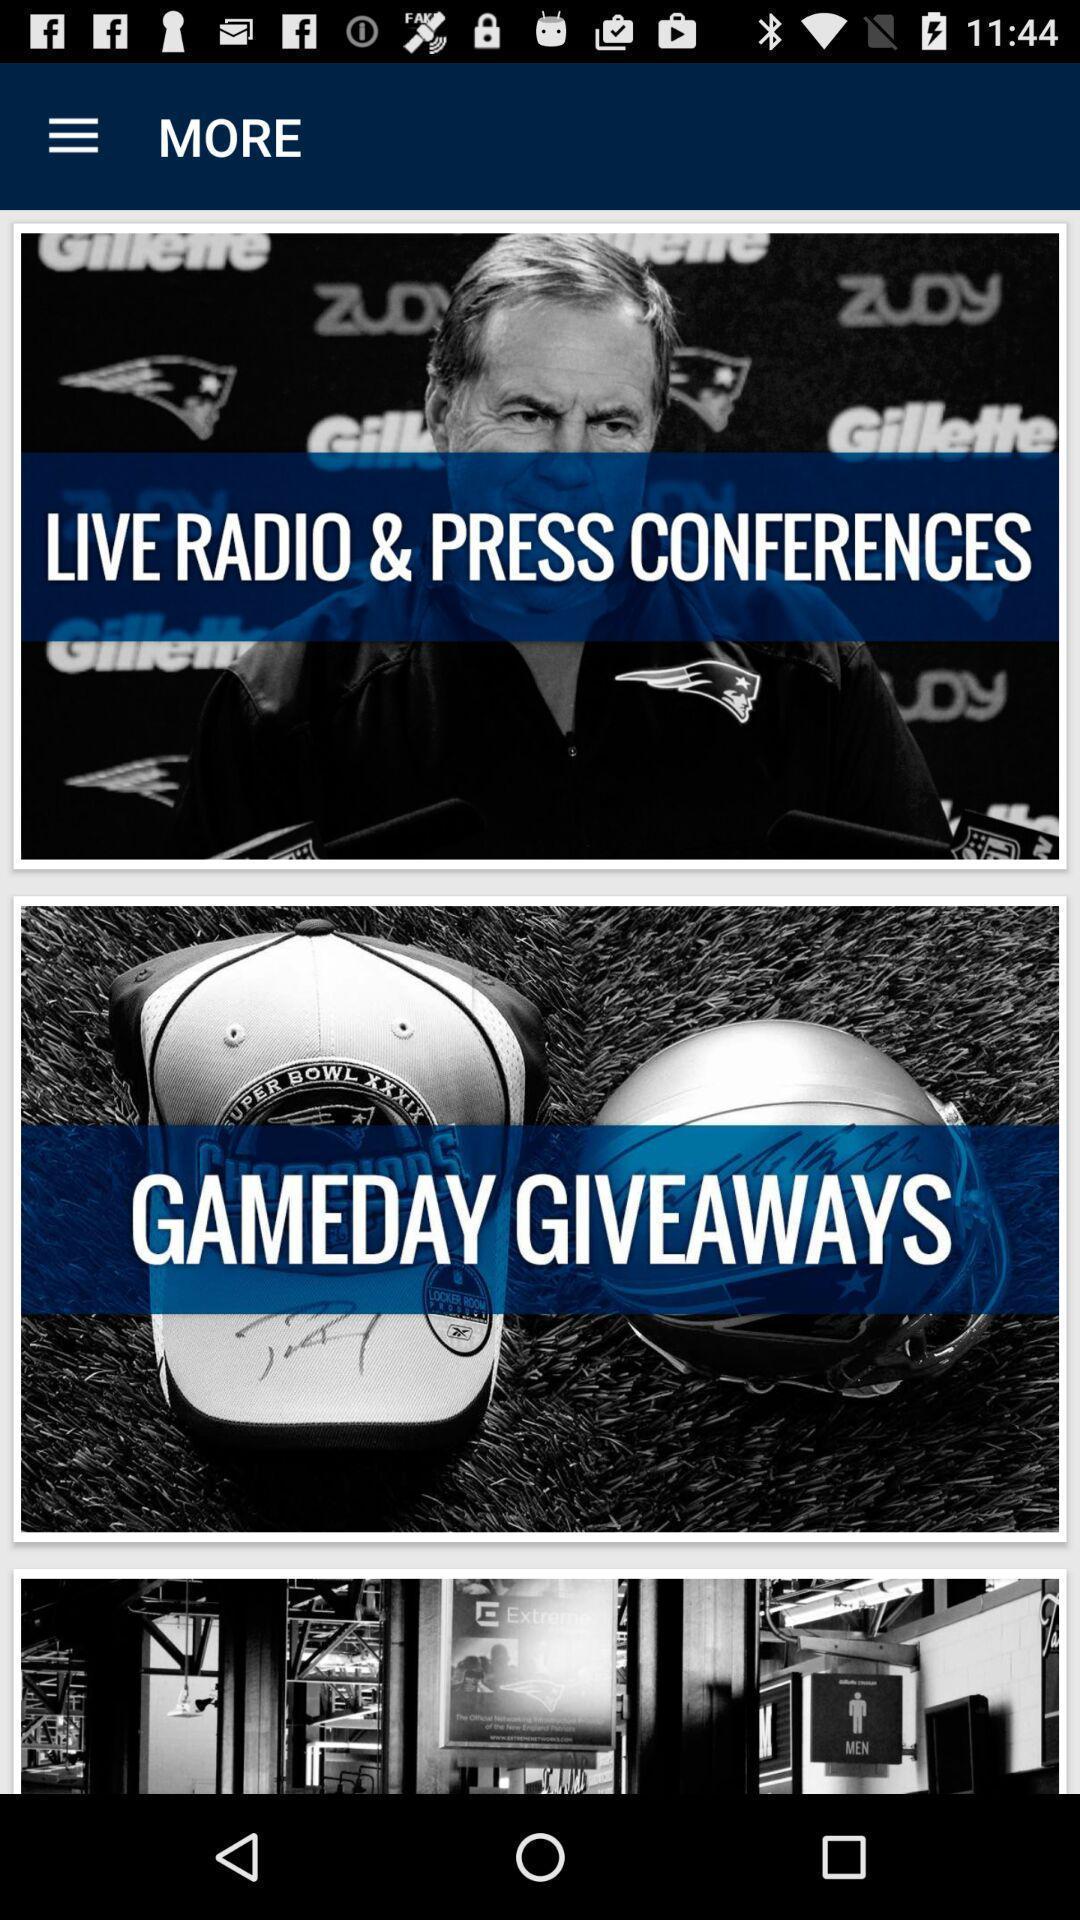Give me a summary of this screen capture. Page displaying different categories of news. 